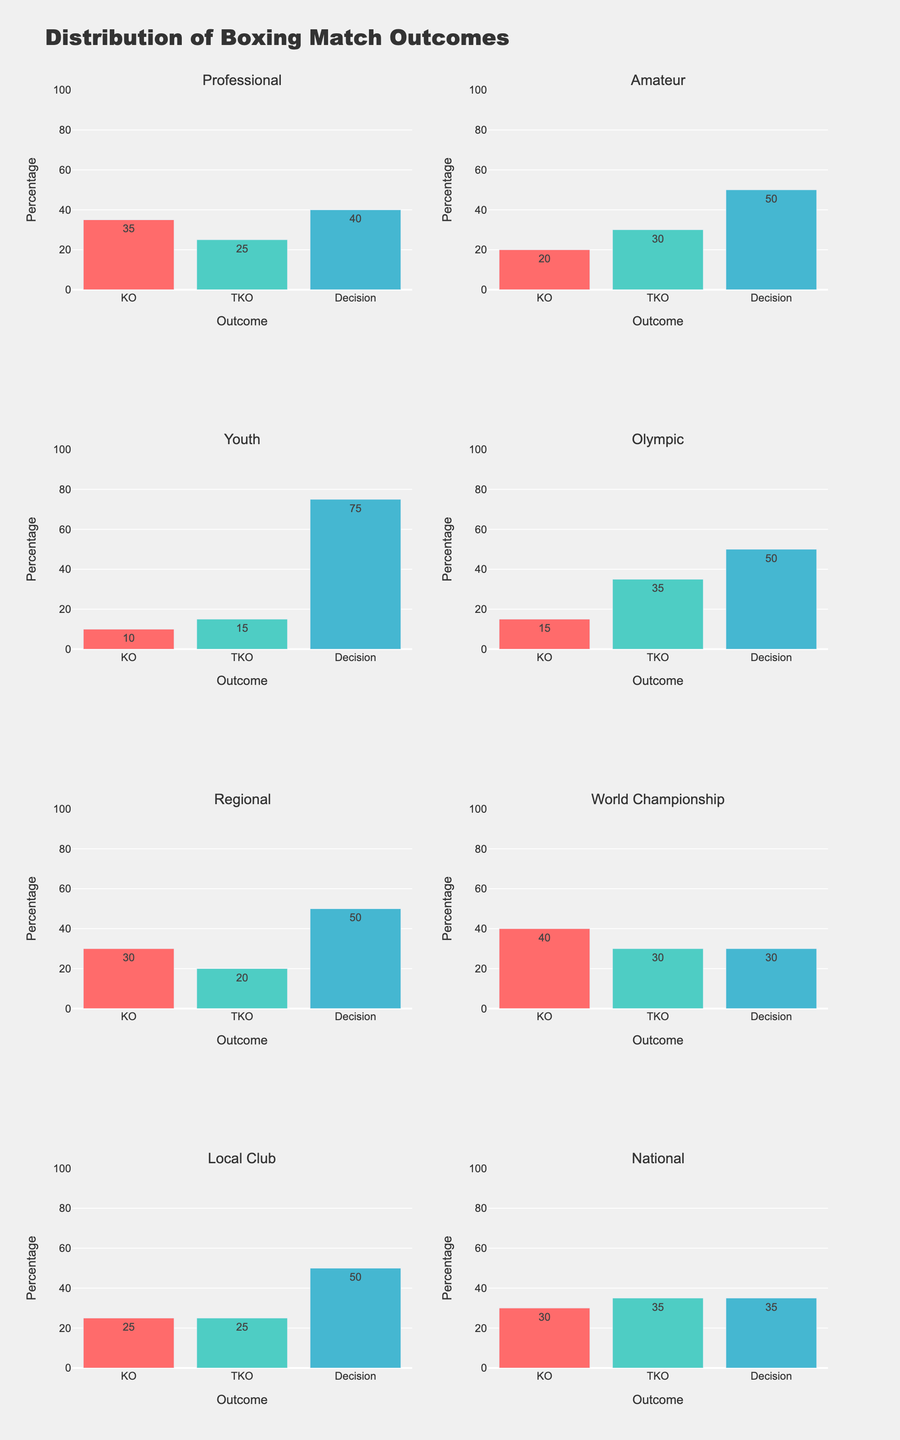What percentage of matches ended in KO at the Professional level? Look at the subplot titled "Professional" and observe the bar corresponding to 'KO'. The height of this bar represents the percentage.
Answer: 35% Which boxing level has the highest percentage of Decision outcomes? Identify the level with the tallest bar for 'Decision' across all subplots. The Youth level has the highest bar for 'Decision' outcomes.
Answer: Youth Compare the KO percentages between Professional and Amateur levels. Which has more and by how much? Look at the KO bars for both Professional and Amateur levels. The Professional level has 35%, and the Amateur level has 20%. The difference is 35% - 20% = 15%.
Answer: Professional, by 15% What is the average percentage of KO outcomes across all levels? Sum the KO values for all levels and divide by the number of levels. The sum is 35 + 20 + 10 + 15 + 30 + 40 + 25 + 30 = 205. There are 8 levels, so the average is 205 / 8 = 25.625.
Answer: 25.625% Which level has an equal distribution of KO, TKO, and Decision outcomes? Scan through subplots to find which has similar heights for KO, TKO, and Decision bars. The Local Club level has 25% for KO, 25% for TKO, and 50% for Decision, which is not equal for KO and TKO. Upon further scanning, no level has an exactly equal distribution.
Answer: None Do Olympic matches have a higher percentage of TKO or KO outcomes? Look at the Olympic subplot and compare the heights of the bars for TKO and KO. TKO has 35%, and KO has 15%, so TKO is higher.
Answer: TKO Which level has the lowest percentage of KO outcomes? Identify the level with the shortest bar for KO across all subplots. The Youth level has the shortest KO bar with 10%.
Answer: Youth How does the percentage of Decision outcomes at the National level compare to that at the Regional level? Look at the Decision bars for National and Regional levels. National has 35%, and Regional has 50%. National has 15% less than Regional.
Answer: Regional has 15% more What is the combined percentage of TKO and Decision outcomes in the World Championship level? Sum the percentages of TKO and Decision at the World Championship level. TKO is 30%, and Decision is 30%, summing to 30% + 30% = 60%.
Answer: 60% Which levels have more TKO outcomes than KO outcomes? Identify levels where the TKO bar is taller than the KO bar. Amateur, Youth, Olympic, and National levels have taller TKO bars compared to KO bars.
Answer: Amateur, Youth, Olympic, National 